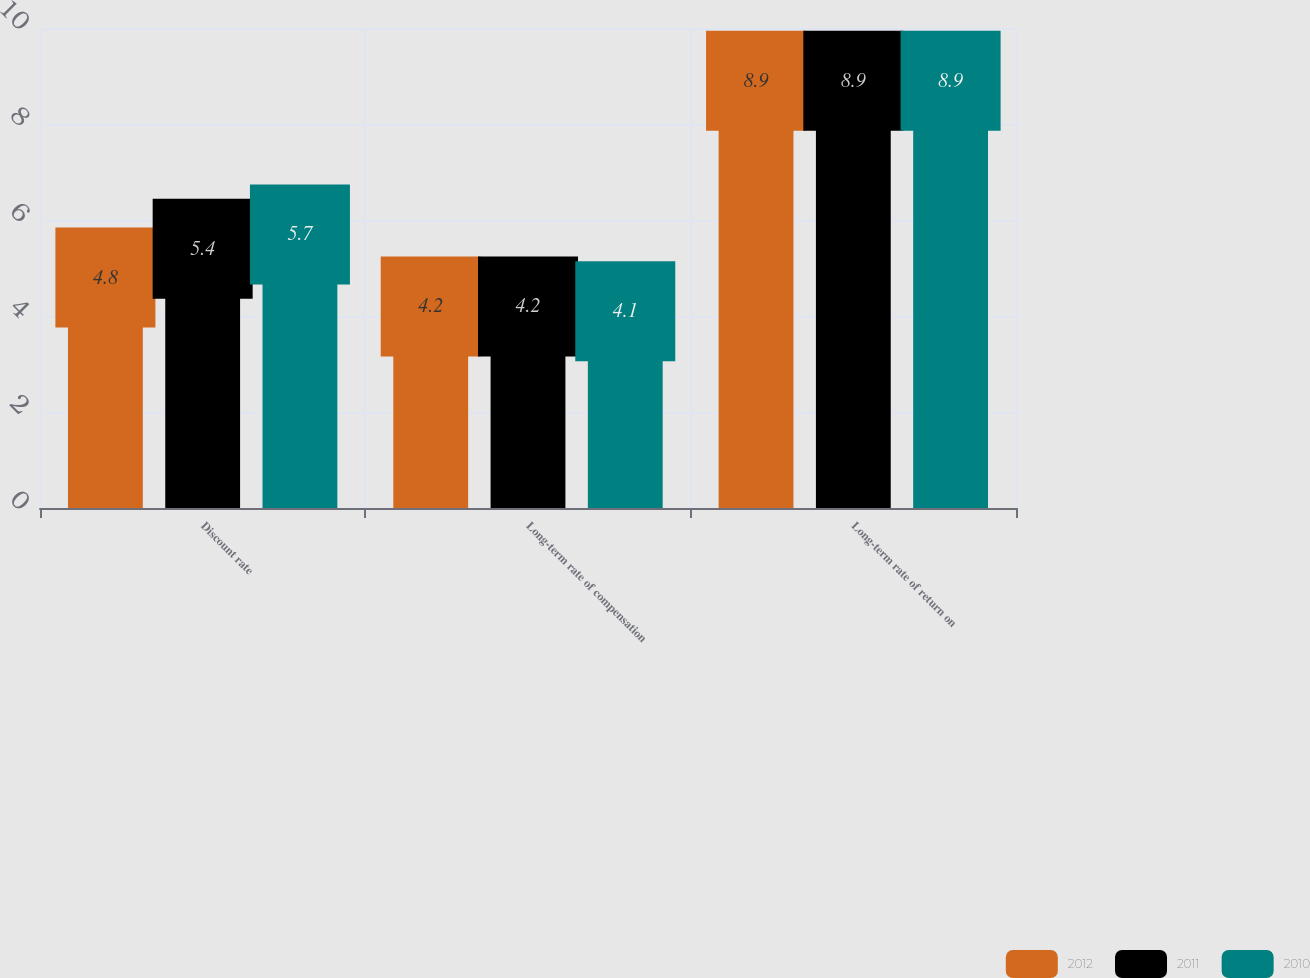Convert chart. <chart><loc_0><loc_0><loc_500><loc_500><stacked_bar_chart><ecel><fcel>Discount rate<fcel>Long-term rate of compensation<fcel>Long-term rate of return on<nl><fcel>2012<fcel>4.8<fcel>4.2<fcel>8.9<nl><fcel>2011<fcel>5.4<fcel>4.2<fcel>8.9<nl><fcel>2010<fcel>5.7<fcel>4.1<fcel>8.9<nl></chart> 